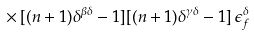Convert formula to latex. <formula><loc_0><loc_0><loc_500><loc_500>\times \, [ ( n + 1 ) \delta ^ { \beta \delta } - 1 ] [ ( n + 1 ) \delta ^ { \gamma \delta } - 1 ] \, \epsilon _ { f } ^ { \delta }</formula> 